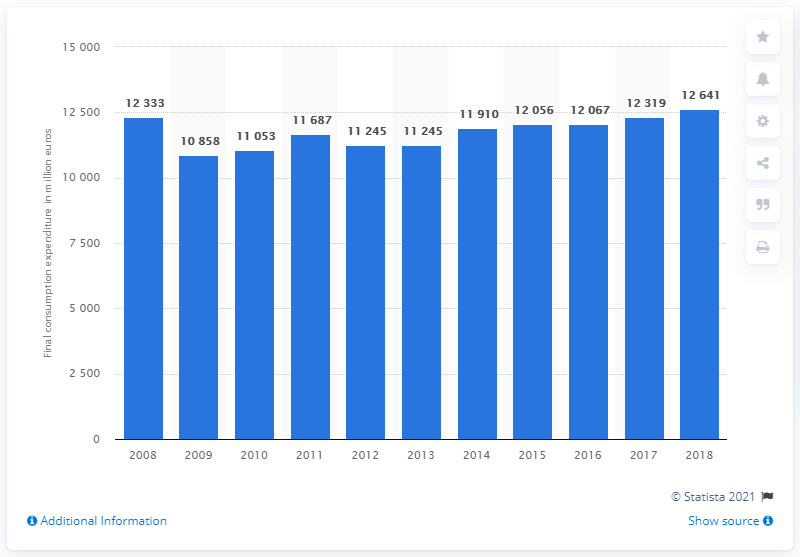Draw attention to some important aspects in this diagram. During the period of 2009 to 2015, Italy's footwear spending was approximately 120,670. In 2018, Italy's expenditure on footwear was 12,641. 